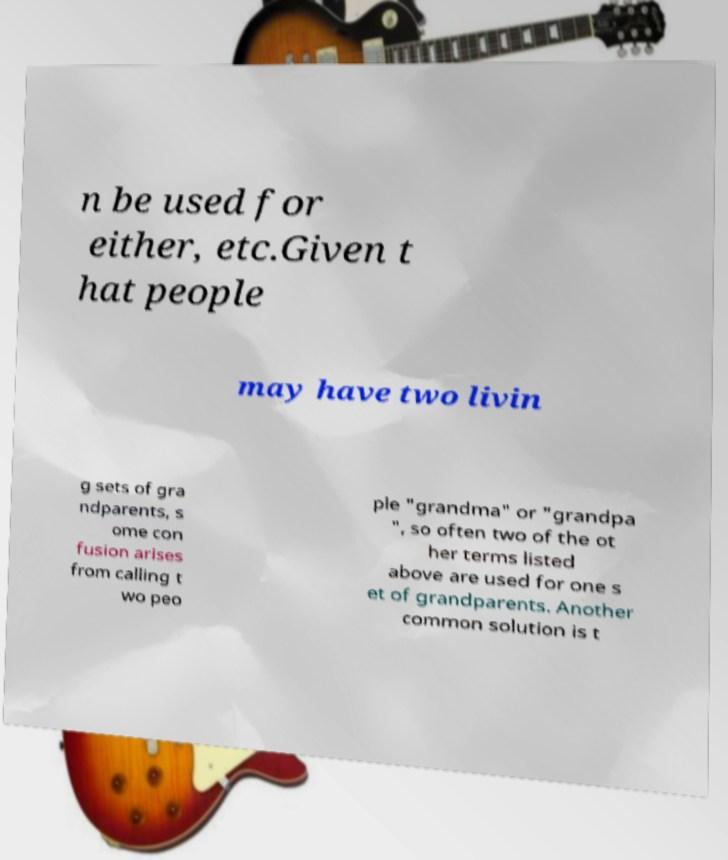There's text embedded in this image that I need extracted. Can you transcribe it verbatim? n be used for either, etc.Given t hat people may have two livin g sets of gra ndparents, s ome con fusion arises from calling t wo peo ple "grandma" or "grandpa ", so often two of the ot her terms listed above are used for one s et of grandparents. Another common solution is t 